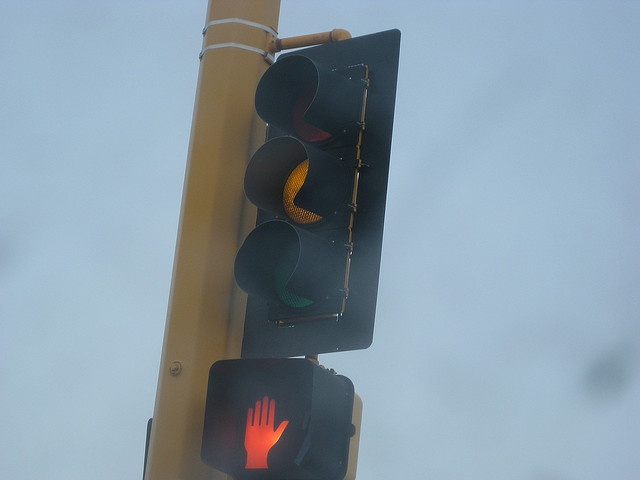Describe the objects in this image and their specific colors. I can see traffic light in lightblue, black, blue, darkblue, and purple tones and traffic light in lightblue, darkblue, gray, and black tones in this image. 